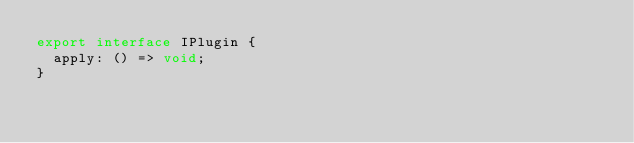<code> <loc_0><loc_0><loc_500><loc_500><_TypeScript_>export interface IPlugin {
  apply: () => void;
}
</code> 